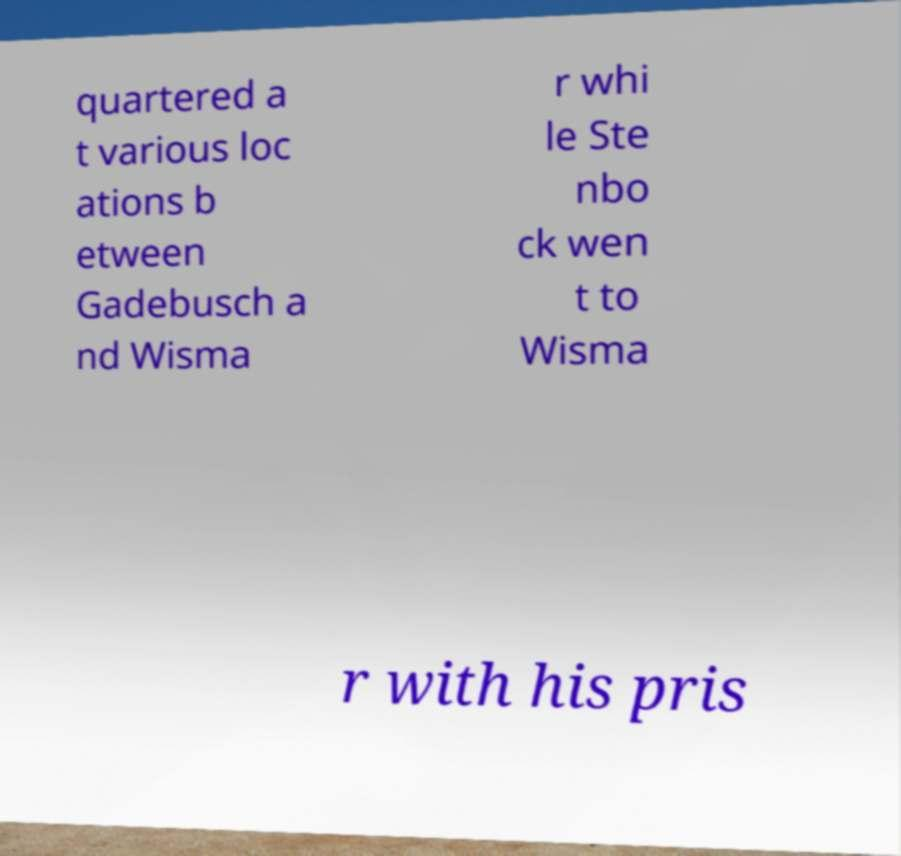For documentation purposes, I need the text within this image transcribed. Could you provide that? quartered a t various loc ations b etween Gadebusch a nd Wisma r whi le Ste nbo ck wen t to Wisma r with his pris 